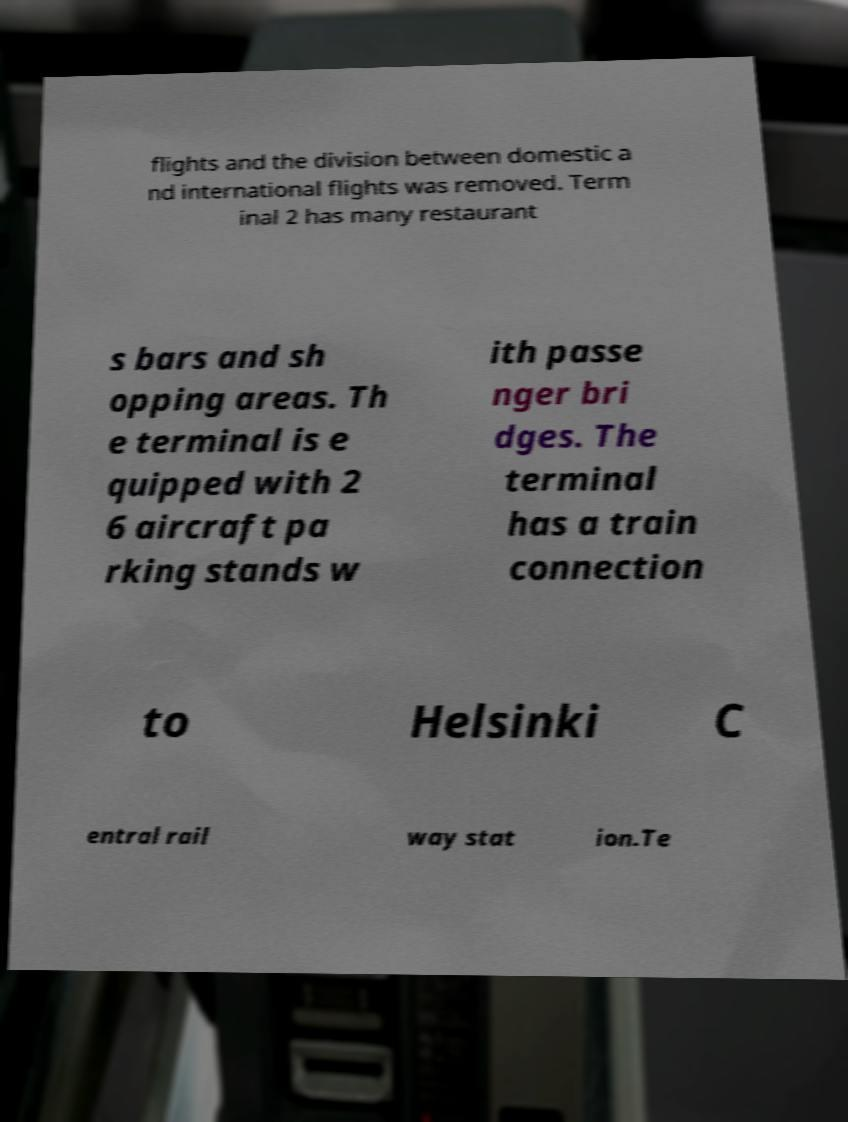For documentation purposes, I need the text within this image transcribed. Could you provide that? flights and the division between domestic a nd international flights was removed. Term inal 2 has many restaurant s bars and sh opping areas. Th e terminal is e quipped with 2 6 aircraft pa rking stands w ith passe nger bri dges. The terminal has a train connection to Helsinki C entral rail way stat ion.Te 